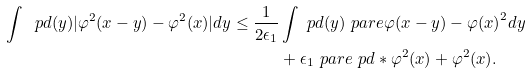Convert formula to latex. <formula><loc_0><loc_0><loc_500><loc_500>\int \ p d ( y ) | \varphi ^ { 2 } ( x - y ) - \varphi ^ { 2 } ( x ) | d y \leq \frac { 1 } { 2 \epsilon _ { 1 } } & \int \ p d ( y ) \ p a r e { \varphi ( x - y ) - \varphi ( x ) } ^ { 2 } d y \\ & + \epsilon _ { 1 } \ p a r e { \ p d * \varphi ^ { 2 } ( x ) + \varphi ^ { 2 } ( x ) } .</formula> 